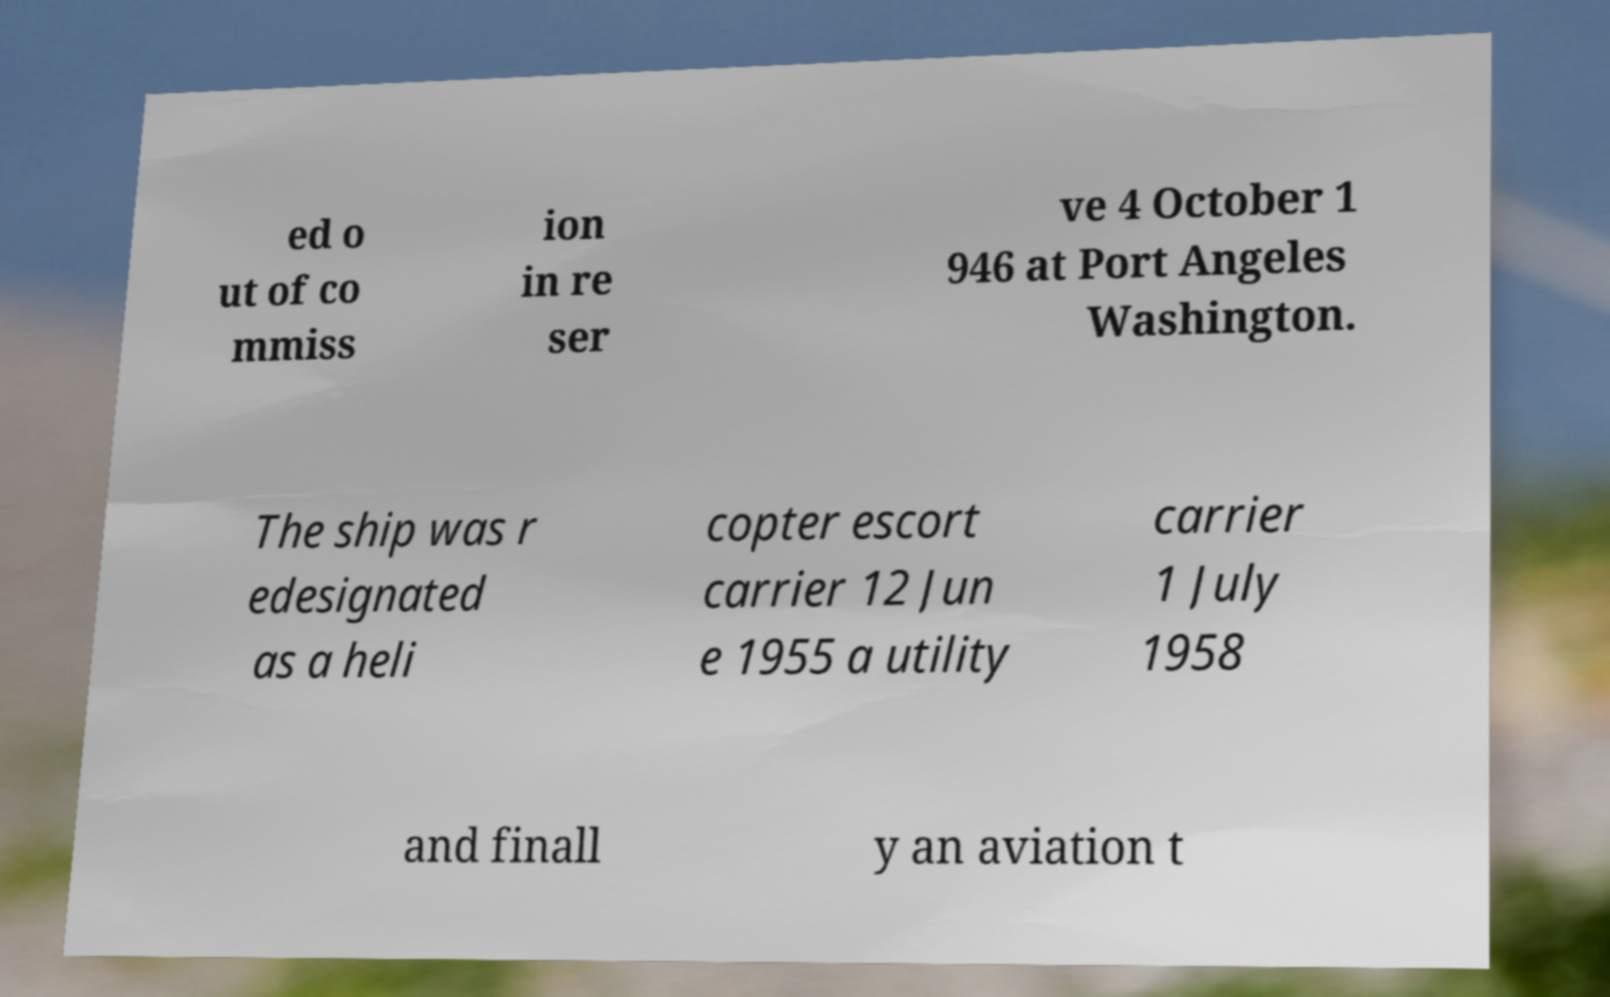For documentation purposes, I need the text within this image transcribed. Could you provide that? ed o ut of co mmiss ion in re ser ve 4 October 1 946 at Port Angeles Washington. The ship was r edesignated as a heli copter escort carrier 12 Jun e 1955 a utility carrier 1 July 1958 and finall y an aviation t 